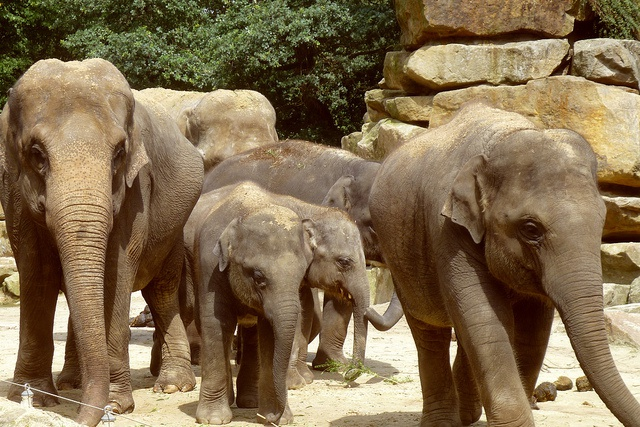Describe the objects in this image and their specific colors. I can see elephant in black, maroon, gray, and tan tones, elephant in black, tan, maroon, and gray tones, elephant in black, tan, and maroon tones, elephant in black, gray, tan, and maroon tones, and elephant in black, gray, and tan tones in this image. 